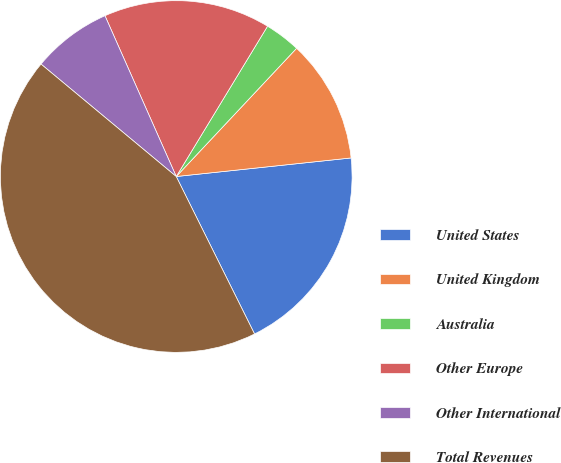<chart> <loc_0><loc_0><loc_500><loc_500><pie_chart><fcel>United States<fcel>United Kingdom<fcel>Australia<fcel>Other Europe<fcel>Other International<fcel>Total Revenues<nl><fcel>19.34%<fcel>11.32%<fcel>3.31%<fcel>15.33%<fcel>7.32%<fcel>43.39%<nl></chart> 